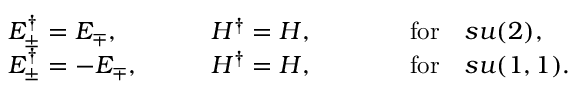<formula> <loc_0><loc_0><loc_500><loc_500>\begin{array} { l l l } { { E _ { \pm } ^ { \dagger } = E _ { \mp } , } } & { { \quad H ^ { \dagger } = H , } } & { \quad f o r \quad s u ( 2 ) , } \\ { { E _ { \pm } ^ { \dagger } = - E _ { \mp } , } } & { { \quad H ^ { \dagger } = H , } } & { \quad f o r \quad s u ( 1 , 1 ) . } \end{array}</formula> 